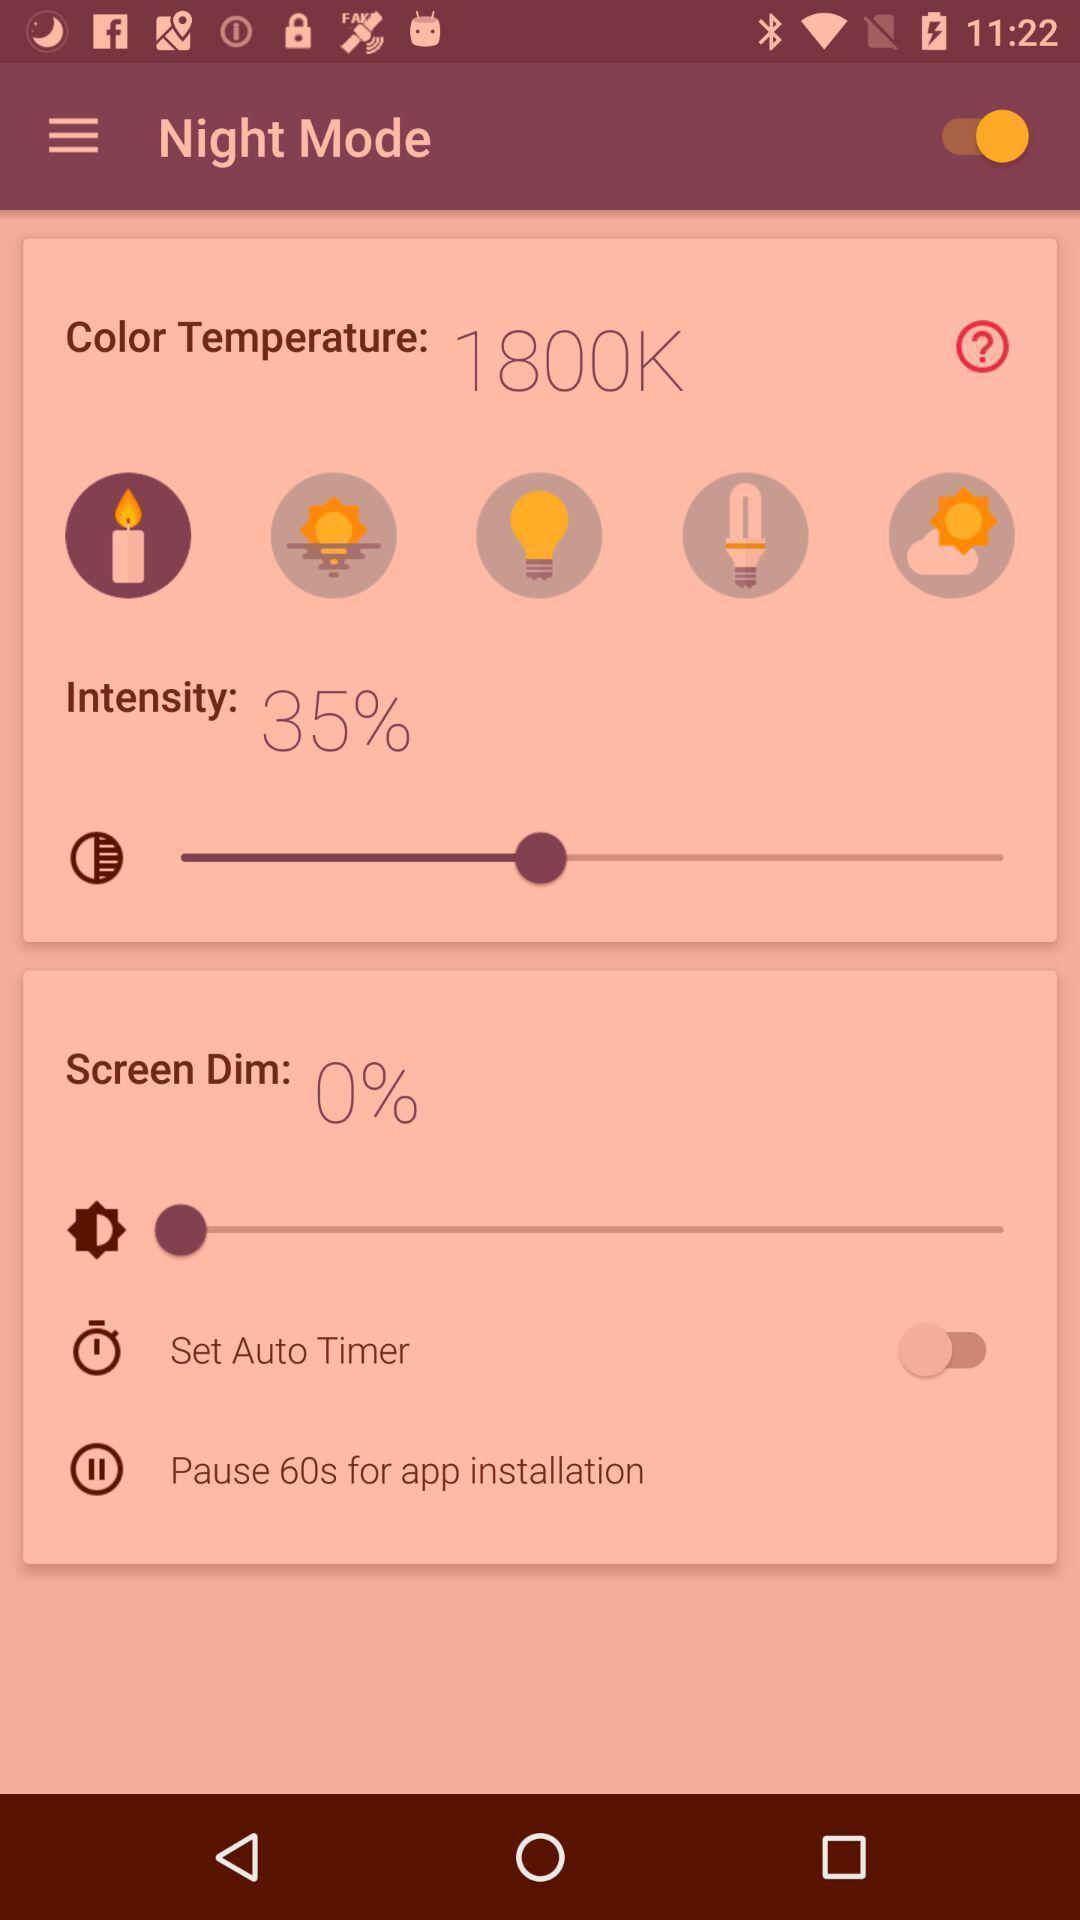Give me a summary of this screen capture. Page shows the screen dim options of night mode. 